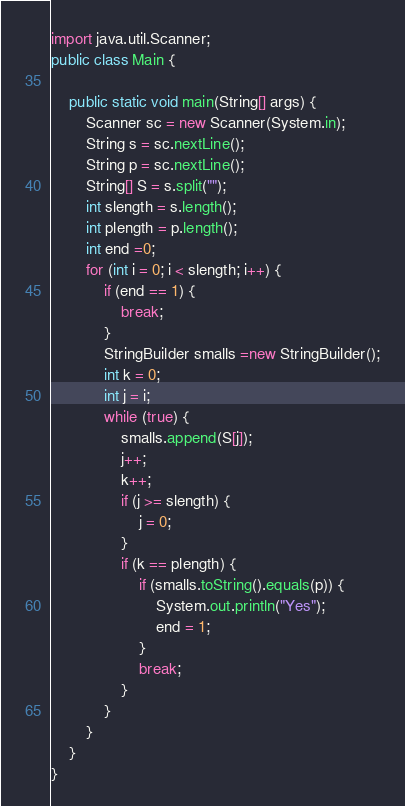Convert code to text. <code><loc_0><loc_0><loc_500><loc_500><_Java_>import java.util.Scanner;
public class Main {

	public static void main(String[] args) {
		Scanner sc = new Scanner(System.in);
		String s = sc.nextLine();
		String p = sc.nextLine();
		String[] S = s.split("");
		int slength = s.length();
		int plength = p.length();
		int end =0;
		for (int i = 0; i < slength; i++) {
			if (end == 1) {
				break;
			}
			StringBuilder smalls =new StringBuilder();
			int k = 0;
			int j = i;
			while (true) {
				smalls.append(S[j]);
				j++;
				k++;
				if (j >= slength) {
					j = 0;
				}
				if (k == plength) {
					if (smalls.toString().equals(p)) {
						System.out.println("Yes");
						end = 1;
					}
					break;
				}
			}
		}
	}
}</code> 